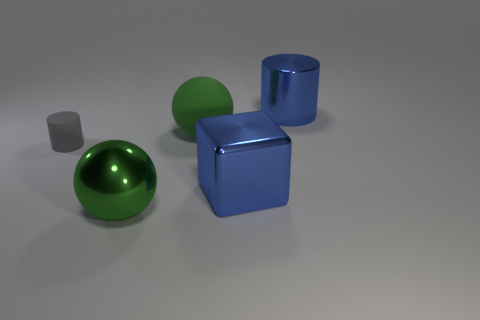Are there more big things to the right of the big green matte sphere than tiny gray metallic balls?
Your answer should be very brief. Yes. There is a metal thing behind the big blue object that is in front of the green ball behind the big blue metal block; what is its color?
Make the answer very short. Blue. Is the material of the tiny cylinder the same as the large cylinder?
Your answer should be compact. No. Is there a yellow matte ball that has the same size as the matte cylinder?
Offer a terse response. No. What material is the green ball that is the same size as the green shiny object?
Provide a succinct answer. Rubber. Is there another green matte thing of the same shape as the tiny object?
Give a very brief answer. No. There is a cylinder that is the same color as the big metal cube; what is its material?
Keep it short and to the point. Metal. What shape is the large metal object that is on the right side of the big shiny block?
Offer a terse response. Cylinder. What number of tiny yellow cubes are there?
Make the answer very short. 0. There is a cylinder that is made of the same material as the cube; what color is it?
Provide a short and direct response. Blue. 